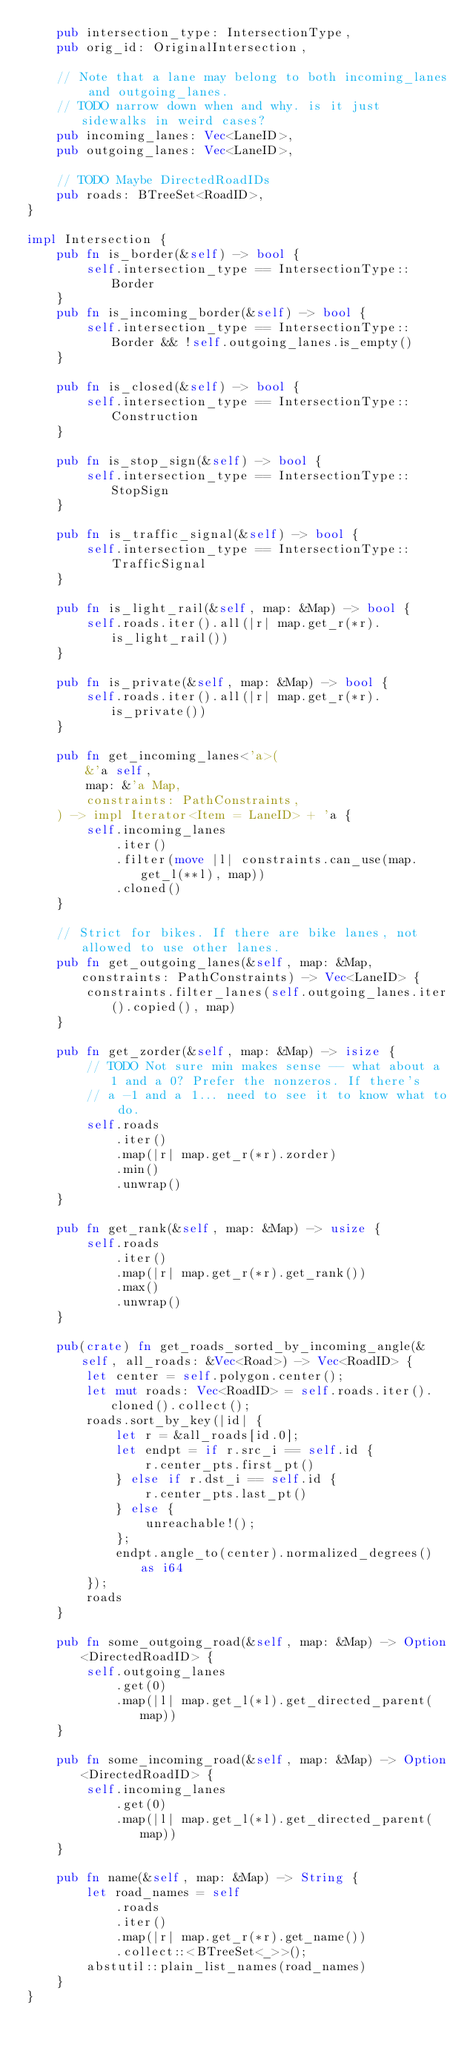Convert code to text. <code><loc_0><loc_0><loc_500><loc_500><_Rust_>    pub intersection_type: IntersectionType,
    pub orig_id: OriginalIntersection,

    // Note that a lane may belong to both incoming_lanes and outgoing_lanes.
    // TODO narrow down when and why. is it just sidewalks in weird cases?
    pub incoming_lanes: Vec<LaneID>,
    pub outgoing_lanes: Vec<LaneID>,

    // TODO Maybe DirectedRoadIDs
    pub roads: BTreeSet<RoadID>,
}

impl Intersection {
    pub fn is_border(&self) -> bool {
        self.intersection_type == IntersectionType::Border
    }
    pub fn is_incoming_border(&self) -> bool {
        self.intersection_type == IntersectionType::Border && !self.outgoing_lanes.is_empty()
    }

    pub fn is_closed(&self) -> bool {
        self.intersection_type == IntersectionType::Construction
    }

    pub fn is_stop_sign(&self) -> bool {
        self.intersection_type == IntersectionType::StopSign
    }

    pub fn is_traffic_signal(&self) -> bool {
        self.intersection_type == IntersectionType::TrafficSignal
    }

    pub fn is_light_rail(&self, map: &Map) -> bool {
        self.roads.iter().all(|r| map.get_r(*r).is_light_rail())
    }

    pub fn is_private(&self, map: &Map) -> bool {
        self.roads.iter().all(|r| map.get_r(*r).is_private())
    }

    pub fn get_incoming_lanes<'a>(
        &'a self,
        map: &'a Map,
        constraints: PathConstraints,
    ) -> impl Iterator<Item = LaneID> + 'a {
        self.incoming_lanes
            .iter()
            .filter(move |l| constraints.can_use(map.get_l(**l), map))
            .cloned()
    }

    // Strict for bikes. If there are bike lanes, not allowed to use other lanes.
    pub fn get_outgoing_lanes(&self, map: &Map, constraints: PathConstraints) -> Vec<LaneID> {
        constraints.filter_lanes(self.outgoing_lanes.iter().copied(), map)
    }

    pub fn get_zorder(&self, map: &Map) -> isize {
        // TODO Not sure min makes sense -- what about a 1 and a 0? Prefer the nonzeros. If there's
        // a -1 and a 1... need to see it to know what to do.
        self.roads
            .iter()
            .map(|r| map.get_r(*r).zorder)
            .min()
            .unwrap()
    }

    pub fn get_rank(&self, map: &Map) -> usize {
        self.roads
            .iter()
            .map(|r| map.get_r(*r).get_rank())
            .max()
            .unwrap()
    }

    pub(crate) fn get_roads_sorted_by_incoming_angle(&self, all_roads: &Vec<Road>) -> Vec<RoadID> {
        let center = self.polygon.center();
        let mut roads: Vec<RoadID> = self.roads.iter().cloned().collect();
        roads.sort_by_key(|id| {
            let r = &all_roads[id.0];
            let endpt = if r.src_i == self.id {
                r.center_pts.first_pt()
            } else if r.dst_i == self.id {
                r.center_pts.last_pt()
            } else {
                unreachable!();
            };
            endpt.angle_to(center).normalized_degrees() as i64
        });
        roads
    }

    pub fn some_outgoing_road(&self, map: &Map) -> Option<DirectedRoadID> {
        self.outgoing_lanes
            .get(0)
            .map(|l| map.get_l(*l).get_directed_parent(map))
    }

    pub fn some_incoming_road(&self, map: &Map) -> Option<DirectedRoadID> {
        self.incoming_lanes
            .get(0)
            .map(|l| map.get_l(*l).get_directed_parent(map))
    }

    pub fn name(&self, map: &Map) -> String {
        let road_names = self
            .roads
            .iter()
            .map(|r| map.get_r(*r).get_name())
            .collect::<BTreeSet<_>>();
        abstutil::plain_list_names(road_names)
    }
}
</code> 